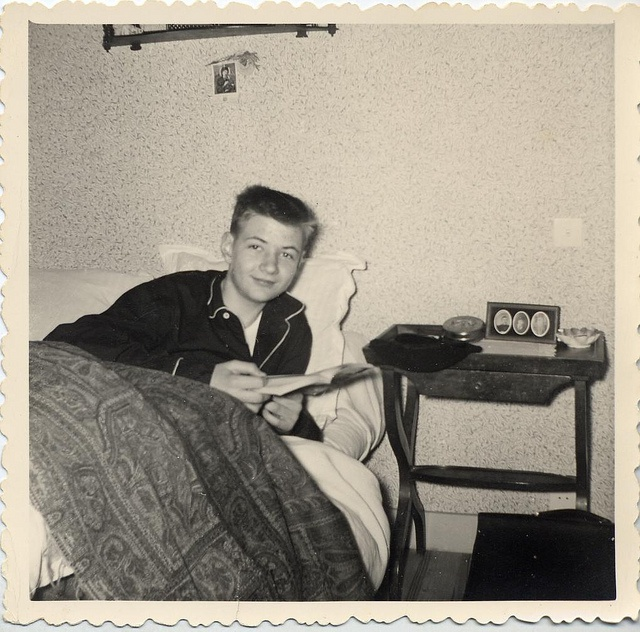Describe the objects in this image and their specific colors. I can see people in white, black, darkgray, and gray tones, bed in white, darkgray, lightgray, and black tones, bed in white, lightgray, and darkgray tones, and book in white, darkgray, gray, black, and lightgray tones in this image. 